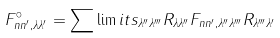Convert formula to latex. <formula><loc_0><loc_0><loc_500><loc_500>F ^ { \circ } _ { n n ^ { \prime } , \lambda \lambda ^ { \prime } } = \sum \lim i t s _ { \lambda ^ { \prime \prime } \lambda ^ { \prime \prime \prime } } R _ { \lambda \lambda ^ { \prime \prime } } F _ { n n ^ { \prime } , \lambda ^ { \prime \prime } \lambda ^ { \prime \prime \prime } } R _ { \lambda ^ { \prime \prime \prime } \lambda ^ { \prime } }</formula> 